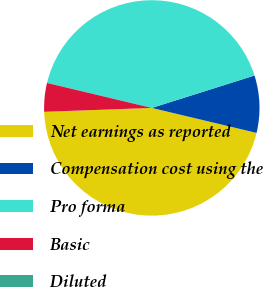Convert chart. <chart><loc_0><loc_0><loc_500><loc_500><pie_chart><fcel>Net earnings as reported<fcel>Compensation cost using the<fcel>Pro forma<fcel>Basic<fcel>Diluted<nl><fcel>45.7%<fcel>8.59%<fcel>41.41%<fcel>4.3%<fcel>0.0%<nl></chart> 